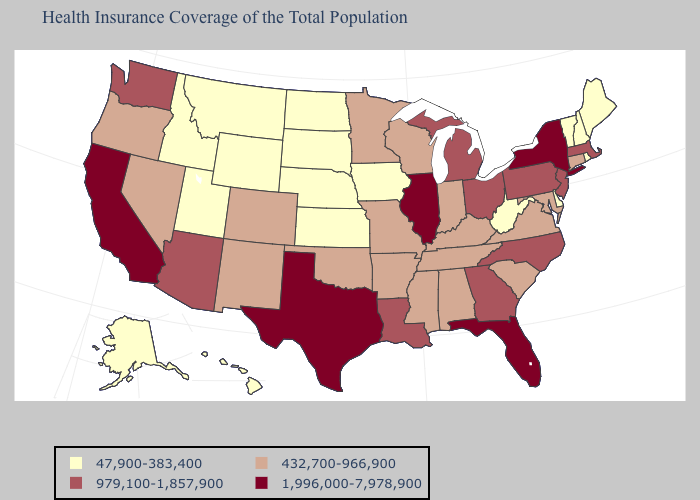Does Wisconsin have the highest value in the MidWest?
Be succinct. No. Name the states that have a value in the range 47,900-383,400?
Be succinct. Alaska, Delaware, Hawaii, Idaho, Iowa, Kansas, Maine, Montana, Nebraska, New Hampshire, North Dakota, Rhode Island, South Dakota, Utah, Vermont, West Virginia, Wyoming. Name the states that have a value in the range 1,996,000-7,978,900?
Answer briefly. California, Florida, Illinois, New York, Texas. Name the states that have a value in the range 979,100-1,857,900?
Be succinct. Arizona, Georgia, Louisiana, Massachusetts, Michigan, New Jersey, North Carolina, Ohio, Pennsylvania, Washington. Name the states that have a value in the range 432,700-966,900?
Be succinct. Alabama, Arkansas, Colorado, Connecticut, Indiana, Kentucky, Maryland, Minnesota, Mississippi, Missouri, Nevada, New Mexico, Oklahoma, Oregon, South Carolina, Tennessee, Virginia, Wisconsin. Does Nevada have the same value as Michigan?
Short answer required. No. What is the highest value in the USA?
Answer briefly. 1,996,000-7,978,900. Does Utah have the highest value in the USA?
Answer briefly. No. What is the value of Louisiana?
Short answer required. 979,100-1,857,900. Name the states that have a value in the range 1,996,000-7,978,900?
Keep it brief. California, Florida, Illinois, New York, Texas. Among the states that border New Hampshire , which have the highest value?
Write a very short answer. Massachusetts. Name the states that have a value in the range 1,996,000-7,978,900?
Quick response, please. California, Florida, Illinois, New York, Texas. What is the value of Georgia?
Answer briefly. 979,100-1,857,900. Does the first symbol in the legend represent the smallest category?
Quick response, please. Yes. Is the legend a continuous bar?
Keep it brief. No. 